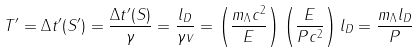<formula> <loc_0><loc_0><loc_500><loc_500>T ^ { \prime } = \Delta t ^ { \prime } ( S ^ { \prime } ) = \frac { \Delta t ^ { \prime } ( S ) } { \gamma } = \frac { l _ { D } } { \gamma v } = \left ( \frac { m _ { \Lambda } c ^ { 2 } } { E } \right ) \left ( \frac { E } { P c ^ { 2 } } \right ) l _ { D } = \frac { m _ { \Lambda } l _ { D } } { P }</formula> 